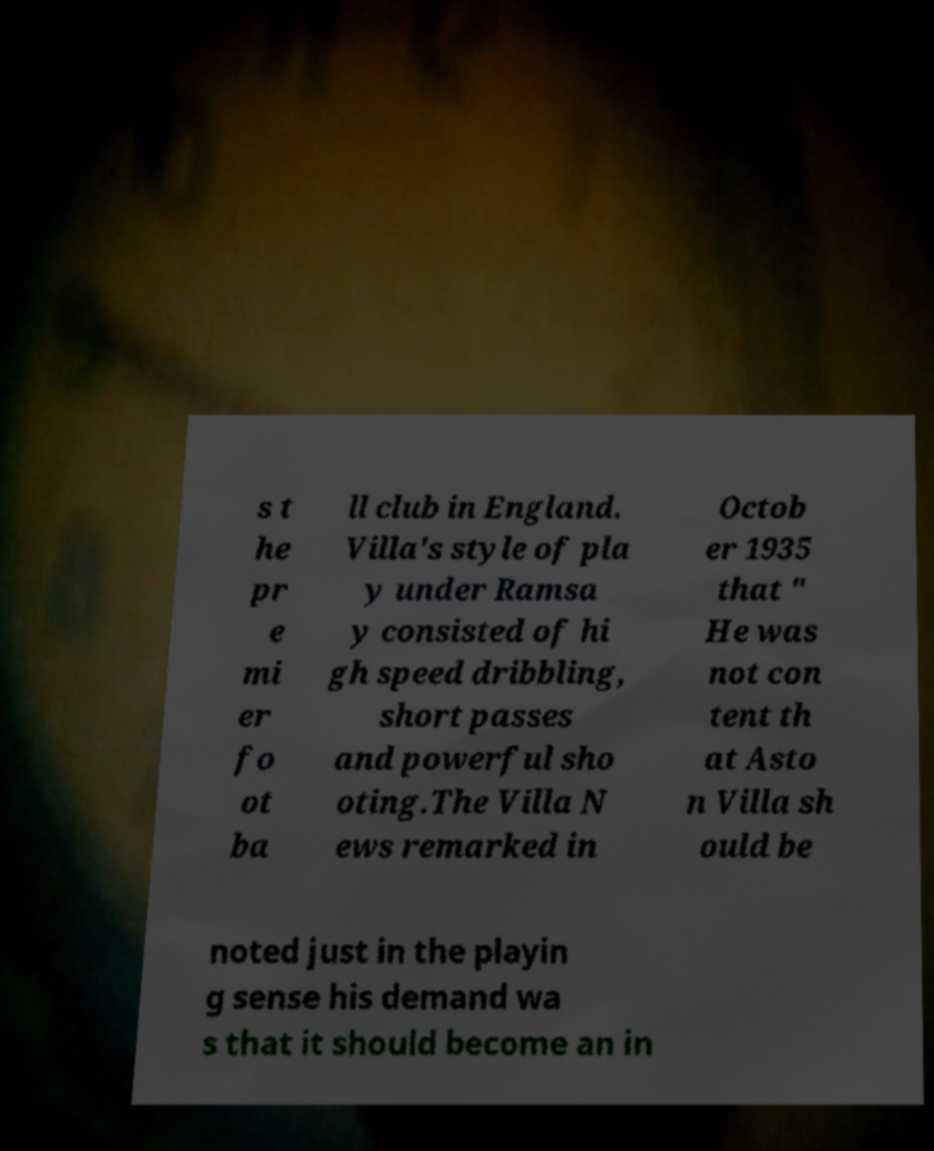What messages or text are displayed in this image? I need them in a readable, typed format. s t he pr e mi er fo ot ba ll club in England. Villa's style of pla y under Ramsa y consisted of hi gh speed dribbling, short passes and powerful sho oting.The Villa N ews remarked in Octob er 1935 that " He was not con tent th at Asto n Villa sh ould be noted just in the playin g sense his demand wa s that it should become an in 